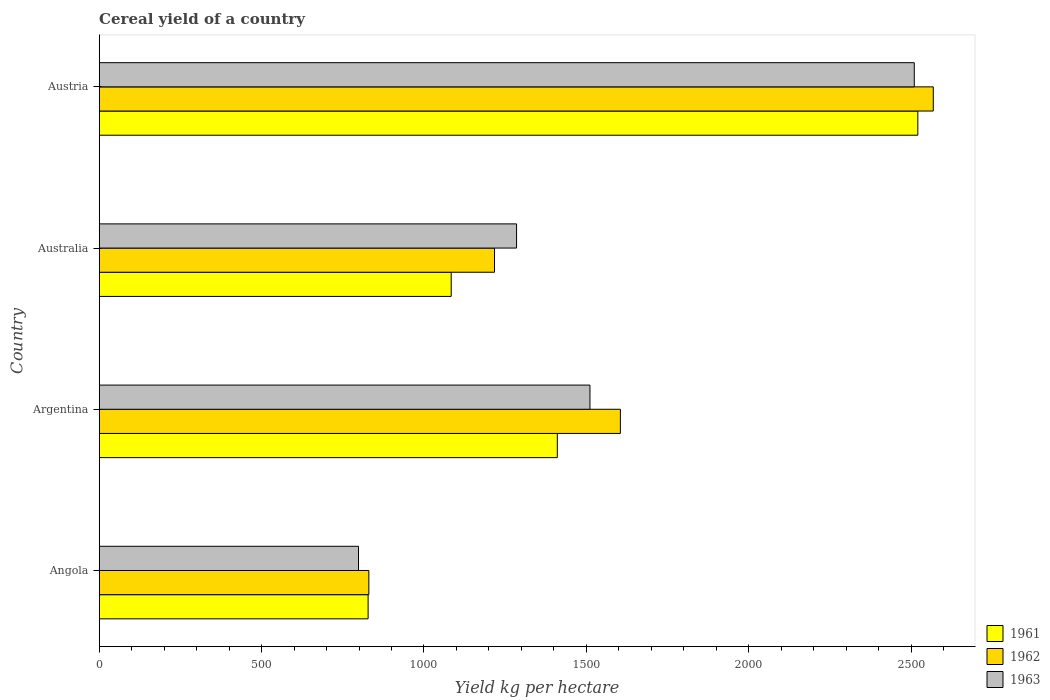How many different coloured bars are there?
Make the answer very short. 3. Are the number of bars per tick equal to the number of legend labels?
Give a very brief answer. Yes. Are the number of bars on each tick of the Y-axis equal?
Ensure brevity in your answer.  Yes. How many bars are there on the 1st tick from the top?
Make the answer very short. 3. How many bars are there on the 1st tick from the bottom?
Your response must be concise. 3. What is the label of the 4th group of bars from the top?
Keep it short and to the point. Angola. What is the total cereal yield in 1962 in Argentina?
Make the answer very short. 1604.92. Across all countries, what is the maximum total cereal yield in 1961?
Keep it short and to the point. 2520.83. Across all countries, what is the minimum total cereal yield in 1962?
Your answer should be very brief. 830.27. In which country was the total cereal yield in 1961 minimum?
Make the answer very short. Angola. What is the total total cereal yield in 1961 in the graph?
Make the answer very short. 5843.39. What is the difference between the total cereal yield in 1963 in Australia and that in Austria?
Your answer should be very brief. -1224.73. What is the difference between the total cereal yield in 1961 in Austria and the total cereal yield in 1963 in Australia?
Your response must be concise. 1235.65. What is the average total cereal yield in 1963 per country?
Offer a terse response. 1526.19. What is the difference between the total cereal yield in 1961 and total cereal yield in 1962 in Angola?
Make the answer very short. -2.27. In how many countries, is the total cereal yield in 1963 greater than 1800 kg per hectare?
Your answer should be very brief. 1. What is the ratio of the total cereal yield in 1963 in Australia to that in Austria?
Offer a very short reply. 0.51. Is the total cereal yield in 1963 in Angola less than that in Austria?
Offer a very short reply. Yes. What is the difference between the highest and the second highest total cereal yield in 1962?
Your answer should be compact. 963.52. What is the difference between the highest and the lowest total cereal yield in 1962?
Your answer should be compact. 1738.17. In how many countries, is the total cereal yield in 1963 greater than the average total cereal yield in 1963 taken over all countries?
Make the answer very short. 1. Is the sum of the total cereal yield in 1963 in Argentina and Australia greater than the maximum total cereal yield in 1962 across all countries?
Keep it short and to the point. Yes. What does the 1st bar from the top in Argentina represents?
Offer a very short reply. 1963. Is it the case that in every country, the sum of the total cereal yield in 1961 and total cereal yield in 1963 is greater than the total cereal yield in 1962?
Your response must be concise. Yes. Are the values on the major ticks of X-axis written in scientific E-notation?
Your response must be concise. No. Does the graph contain grids?
Your response must be concise. No. How many legend labels are there?
Your answer should be very brief. 3. What is the title of the graph?
Your response must be concise. Cereal yield of a country. What is the label or title of the X-axis?
Your answer should be very brief. Yield kg per hectare. What is the Yield kg per hectare of 1961 in Angola?
Offer a terse response. 828.01. What is the Yield kg per hectare in 1962 in Angola?
Offer a terse response. 830.27. What is the Yield kg per hectare of 1963 in Angola?
Ensure brevity in your answer.  798.45. What is the Yield kg per hectare of 1961 in Argentina?
Your response must be concise. 1410.65. What is the Yield kg per hectare in 1962 in Argentina?
Make the answer very short. 1604.92. What is the Yield kg per hectare of 1963 in Argentina?
Your response must be concise. 1511.24. What is the Yield kg per hectare of 1961 in Australia?
Make the answer very short. 1083.9. What is the Yield kg per hectare in 1962 in Australia?
Your answer should be compact. 1217.27. What is the Yield kg per hectare in 1963 in Australia?
Your answer should be compact. 1285.17. What is the Yield kg per hectare in 1961 in Austria?
Provide a short and direct response. 2520.83. What is the Yield kg per hectare in 1962 in Austria?
Your answer should be compact. 2568.45. What is the Yield kg per hectare of 1963 in Austria?
Provide a short and direct response. 2509.91. Across all countries, what is the maximum Yield kg per hectare of 1961?
Your response must be concise. 2520.83. Across all countries, what is the maximum Yield kg per hectare of 1962?
Your answer should be compact. 2568.45. Across all countries, what is the maximum Yield kg per hectare in 1963?
Provide a succinct answer. 2509.91. Across all countries, what is the minimum Yield kg per hectare in 1961?
Provide a succinct answer. 828.01. Across all countries, what is the minimum Yield kg per hectare of 1962?
Offer a very short reply. 830.27. Across all countries, what is the minimum Yield kg per hectare of 1963?
Your answer should be very brief. 798.45. What is the total Yield kg per hectare in 1961 in the graph?
Ensure brevity in your answer.  5843.39. What is the total Yield kg per hectare in 1962 in the graph?
Provide a succinct answer. 6220.92. What is the total Yield kg per hectare of 1963 in the graph?
Your answer should be very brief. 6104.77. What is the difference between the Yield kg per hectare of 1961 in Angola and that in Argentina?
Your answer should be very brief. -582.65. What is the difference between the Yield kg per hectare in 1962 in Angola and that in Argentina?
Provide a short and direct response. -774.65. What is the difference between the Yield kg per hectare in 1963 in Angola and that in Argentina?
Provide a short and direct response. -712.79. What is the difference between the Yield kg per hectare in 1961 in Angola and that in Australia?
Make the answer very short. -255.9. What is the difference between the Yield kg per hectare of 1962 in Angola and that in Australia?
Your answer should be compact. -387. What is the difference between the Yield kg per hectare of 1963 in Angola and that in Australia?
Give a very brief answer. -486.72. What is the difference between the Yield kg per hectare of 1961 in Angola and that in Austria?
Your answer should be compact. -1692.82. What is the difference between the Yield kg per hectare in 1962 in Angola and that in Austria?
Provide a succinct answer. -1738.17. What is the difference between the Yield kg per hectare in 1963 in Angola and that in Austria?
Your answer should be very brief. -1711.45. What is the difference between the Yield kg per hectare of 1961 in Argentina and that in Australia?
Ensure brevity in your answer.  326.75. What is the difference between the Yield kg per hectare of 1962 in Argentina and that in Australia?
Offer a very short reply. 387.65. What is the difference between the Yield kg per hectare in 1963 in Argentina and that in Australia?
Provide a succinct answer. 226.07. What is the difference between the Yield kg per hectare in 1961 in Argentina and that in Austria?
Your answer should be very brief. -1110.17. What is the difference between the Yield kg per hectare of 1962 in Argentina and that in Austria?
Your response must be concise. -963.52. What is the difference between the Yield kg per hectare of 1963 in Argentina and that in Austria?
Provide a succinct answer. -998.66. What is the difference between the Yield kg per hectare in 1961 in Australia and that in Austria?
Offer a terse response. -1436.93. What is the difference between the Yield kg per hectare in 1962 in Australia and that in Austria?
Your response must be concise. -1351.18. What is the difference between the Yield kg per hectare of 1963 in Australia and that in Austria?
Provide a short and direct response. -1224.73. What is the difference between the Yield kg per hectare of 1961 in Angola and the Yield kg per hectare of 1962 in Argentina?
Your response must be concise. -776.92. What is the difference between the Yield kg per hectare in 1961 in Angola and the Yield kg per hectare in 1963 in Argentina?
Your answer should be very brief. -683.24. What is the difference between the Yield kg per hectare of 1962 in Angola and the Yield kg per hectare of 1963 in Argentina?
Your response must be concise. -680.97. What is the difference between the Yield kg per hectare of 1961 in Angola and the Yield kg per hectare of 1962 in Australia?
Provide a short and direct response. -389.26. What is the difference between the Yield kg per hectare in 1961 in Angola and the Yield kg per hectare in 1963 in Australia?
Offer a terse response. -457.17. What is the difference between the Yield kg per hectare of 1962 in Angola and the Yield kg per hectare of 1963 in Australia?
Your answer should be very brief. -454.9. What is the difference between the Yield kg per hectare of 1961 in Angola and the Yield kg per hectare of 1962 in Austria?
Make the answer very short. -1740.44. What is the difference between the Yield kg per hectare in 1961 in Angola and the Yield kg per hectare in 1963 in Austria?
Your answer should be very brief. -1681.9. What is the difference between the Yield kg per hectare of 1962 in Angola and the Yield kg per hectare of 1963 in Austria?
Provide a succinct answer. -1679.63. What is the difference between the Yield kg per hectare of 1961 in Argentina and the Yield kg per hectare of 1962 in Australia?
Keep it short and to the point. 193.38. What is the difference between the Yield kg per hectare of 1961 in Argentina and the Yield kg per hectare of 1963 in Australia?
Give a very brief answer. 125.48. What is the difference between the Yield kg per hectare in 1962 in Argentina and the Yield kg per hectare in 1963 in Australia?
Your answer should be very brief. 319.75. What is the difference between the Yield kg per hectare in 1961 in Argentina and the Yield kg per hectare in 1962 in Austria?
Give a very brief answer. -1157.79. What is the difference between the Yield kg per hectare in 1961 in Argentina and the Yield kg per hectare in 1963 in Austria?
Provide a short and direct response. -1099.25. What is the difference between the Yield kg per hectare of 1962 in Argentina and the Yield kg per hectare of 1963 in Austria?
Your answer should be very brief. -904.98. What is the difference between the Yield kg per hectare in 1961 in Australia and the Yield kg per hectare in 1962 in Austria?
Your response must be concise. -1484.55. What is the difference between the Yield kg per hectare of 1961 in Australia and the Yield kg per hectare of 1963 in Austria?
Your response must be concise. -1426. What is the difference between the Yield kg per hectare of 1962 in Australia and the Yield kg per hectare of 1963 in Austria?
Make the answer very short. -1292.63. What is the average Yield kg per hectare in 1961 per country?
Give a very brief answer. 1460.85. What is the average Yield kg per hectare of 1962 per country?
Your response must be concise. 1555.23. What is the average Yield kg per hectare of 1963 per country?
Ensure brevity in your answer.  1526.19. What is the difference between the Yield kg per hectare in 1961 and Yield kg per hectare in 1962 in Angola?
Your response must be concise. -2.27. What is the difference between the Yield kg per hectare of 1961 and Yield kg per hectare of 1963 in Angola?
Provide a succinct answer. 29.56. What is the difference between the Yield kg per hectare of 1962 and Yield kg per hectare of 1963 in Angola?
Offer a very short reply. 31.82. What is the difference between the Yield kg per hectare in 1961 and Yield kg per hectare in 1962 in Argentina?
Your answer should be compact. -194.27. What is the difference between the Yield kg per hectare in 1961 and Yield kg per hectare in 1963 in Argentina?
Offer a very short reply. -100.59. What is the difference between the Yield kg per hectare in 1962 and Yield kg per hectare in 1963 in Argentina?
Provide a short and direct response. 93.68. What is the difference between the Yield kg per hectare of 1961 and Yield kg per hectare of 1962 in Australia?
Your answer should be compact. -133.37. What is the difference between the Yield kg per hectare of 1961 and Yield kg per hectare of 1963 in Australia?
Offer a terse response. -201.27. What is the difference between the Yield kg per hectare of 1962 and Yield kg per hectare of 1963 in Australia?
Your answer should be compact. -67.9. What is the difference between the Yield kg per hectare in 1961 and Yield kg per hectare in 1962 in Austria?
Your answer should be compact. -47.62. What is the difference between the Yield kg per hectare in 1961 and Yield kg per hectare in 1963 in Austria?
Provide a short and direct response. 10.92. What is the difference between the Yield kg per hectare of 1962 and Yield kg per hectare of 1963 in Austria?
Offer a very short reply. 58.54. What is the ratio of the Yield kg per hectare of 1961 in Angola to that in Argentina?
Ensure brevity in your answer.  0.59. What is the ratio of the Yield kg per hectare in 1962 in Angola to that in Argentina?
Offer a very short reply. 0.52. What is the ratio of the Yield kg per hectare of 1963 in Angola to that in Argentina?
Give a very brief answer. 0.53. What is the ratio of the Yield kg per hectare in 1961 in Angola to that in Australia?
Offer a terse response. 0.76. What is the ratio of the Yield kg per hectare in 1962 in Angola to that in Australia?
Your answer should be compact. 0.68. What is the ratio of the Yield kg per hectare of 1963 in Angola to that in Australia?
Provide a succinct answer. 0.62. What is the ratio of the Yield kg per hectare of 1961 in Angola to that in Austria?
Your answer should be very brief. 0.33. What is the ratio of the Yield kg per hectare of 1962 in Angola to that in Austria?
Your answer should be very brief. 0.32. What is the ratio of the Yield kg per hectare of 1963 in Angola to that in Austria?
Keep it short and to the point. 0.32. What is the ratio of the Yield kg per hectare of 1961 in Argentina to that in Australia?
Your response must be concise. 1.3. What is the ratio of the Yield kg per hectare in 1962 in Argentina to that in Australia?
Your answer should be very brief. 1.32. What is the ratio of the Yield kg per hectare in 1963 in Argentina to that in Australia?
Make the answer very short. 1.18. What is the ratio of the Yield kg per hectare of 1961 in Argentina to that in Austria?
Provide a succinct answer. 0.56. What is the ratio of the Yield kg per hectare of 1962 in Argentina to that in Austria?
Your answer should be compact. 0.62. What is the ratio of the Yield kg per hectare of 1963 in Argentina to that in Austria?
Your answer should be very brief. 0.6. What is the ratio of the Yield kg per hectare in 1961 in Australia to that in Austria?
Make the answer very short. 0.43. What is the ratio of the Yield kg per hectare of 1962 in Australia to that in Austria?
Your response must be concise. 0.47. What is the ratio of the Yield kg per hectare of 1963 in Australia to that in Austria?
Give a very brief answer. 0.51. What is the difference between the highest and the second highest Yield kg per hectare in 1961?
Give a very brief answer. 1110.17. What is the difference between the highest and the second highest Yield kg per hectare in 1962?
Provide a succinct answer. 963.52. What is the difference between the highest and the second highest Yield kg per hectare of 1963?
Give a very brief answer. 998.66. What is the difference between the highest and the lowest Yield kg per hectare in 1961?
Keep it short and to the point. 1692.82. What is the difference between the highest and the lowest Yield kg per hectare in 1962?
Your answer should be very brief. 1738.17. What is the difference between the highest and the lowest Yield kg per hectare in 1963?
Your response must be concise. 1711.45. 